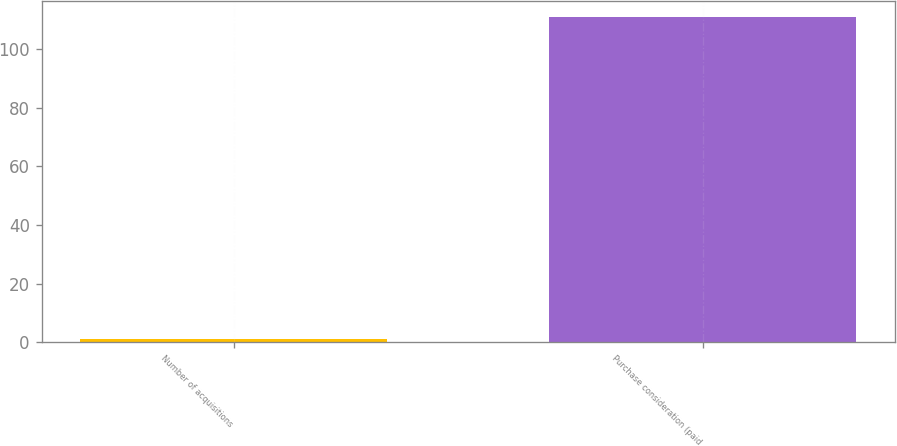Convert chart. <chart><loc_0><loc_0><loc_500><loc_500><bar_chart><fcel>Number of acquisitions<fcel>Purchase consideration (paid<nl><fcel>1<fcel>111<nl></chart> 